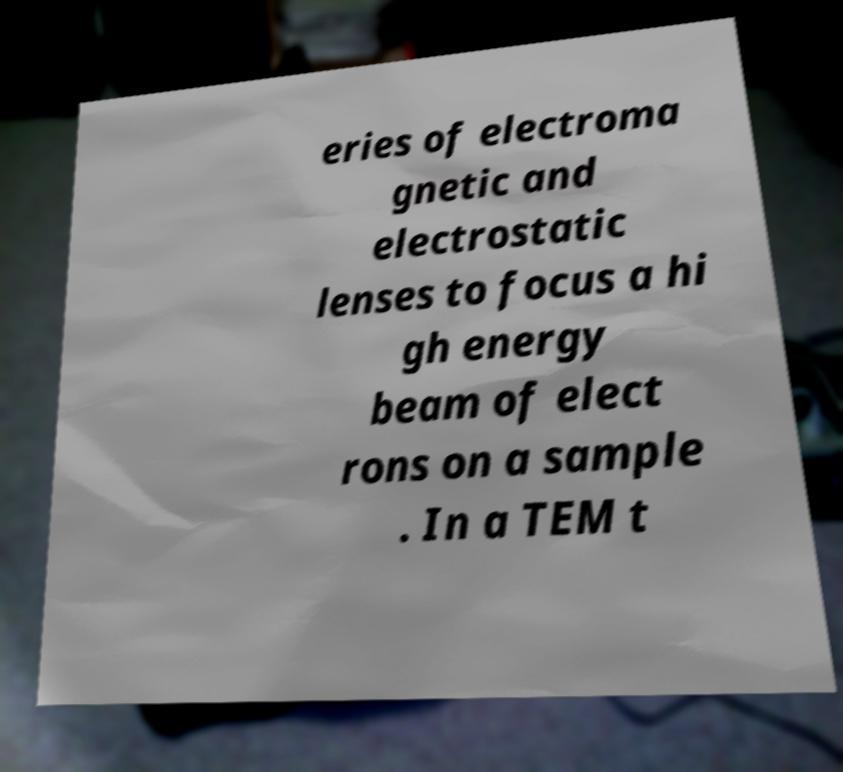Could you assist in decoding the text presented in this image and type it out clearly? eries of electroma gnetic and electrostatic lenses to focus a hi gh energy beam of elect rons on a sample . In a TEM t 